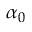<formula> <loc_0><loc_0><loc_500><loc_500>\alpha _ { 0 }</formula> 